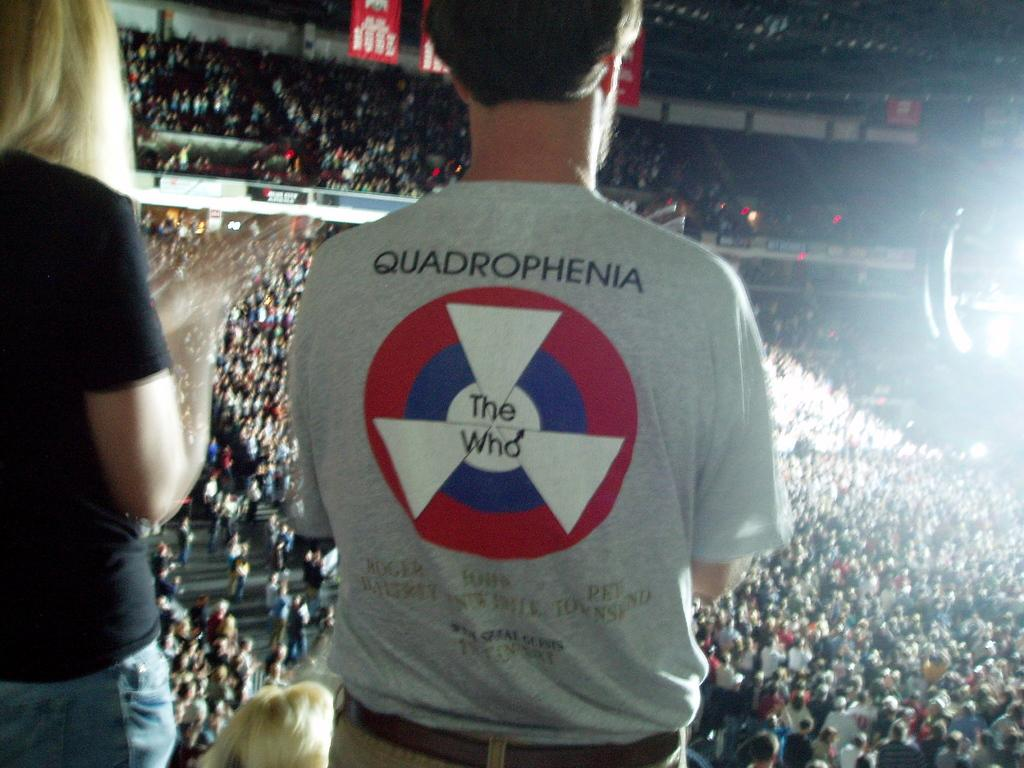Provide a one-sentence caption for the provided image. a person in a THE WHO concert shirt looking out over a crowded arena. 